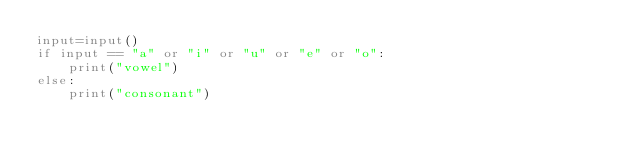Convert code to text. <code><loc_0><loc_0><loc_500><loc_500><_Python_>input=input()
if input == "a" or "i" or "u" or "e" or "o":
    print("vowel")
else:
    print("consonant")</code> 